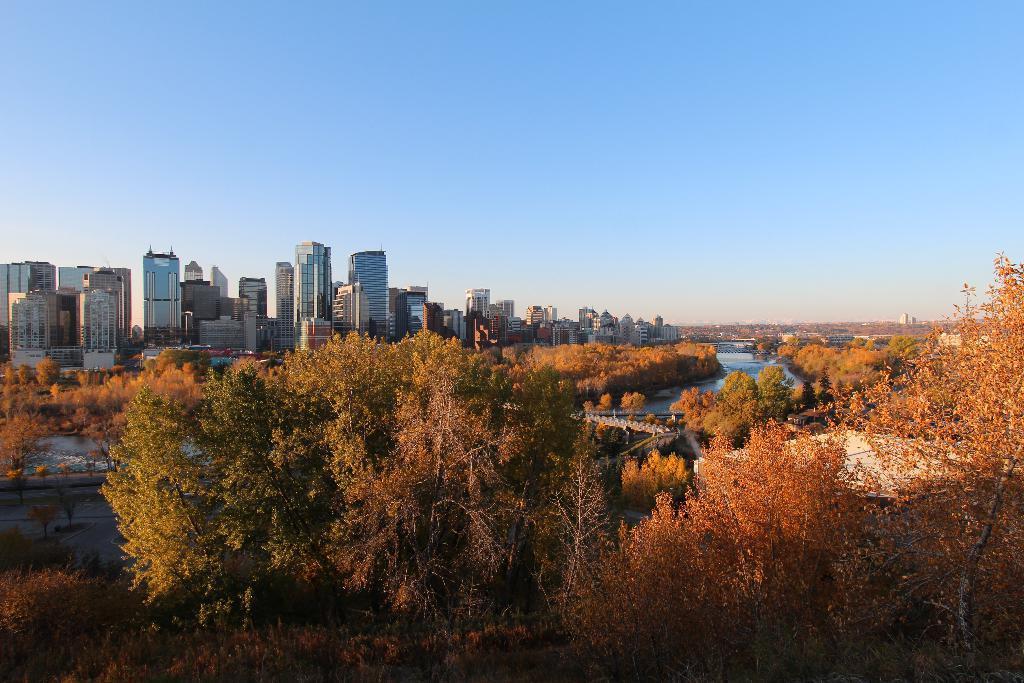How would you summarize this image in a sentence or two? In the image there are many tall buildings and in front of those buildings there are plenty of trees and in between the trees there is a river. 